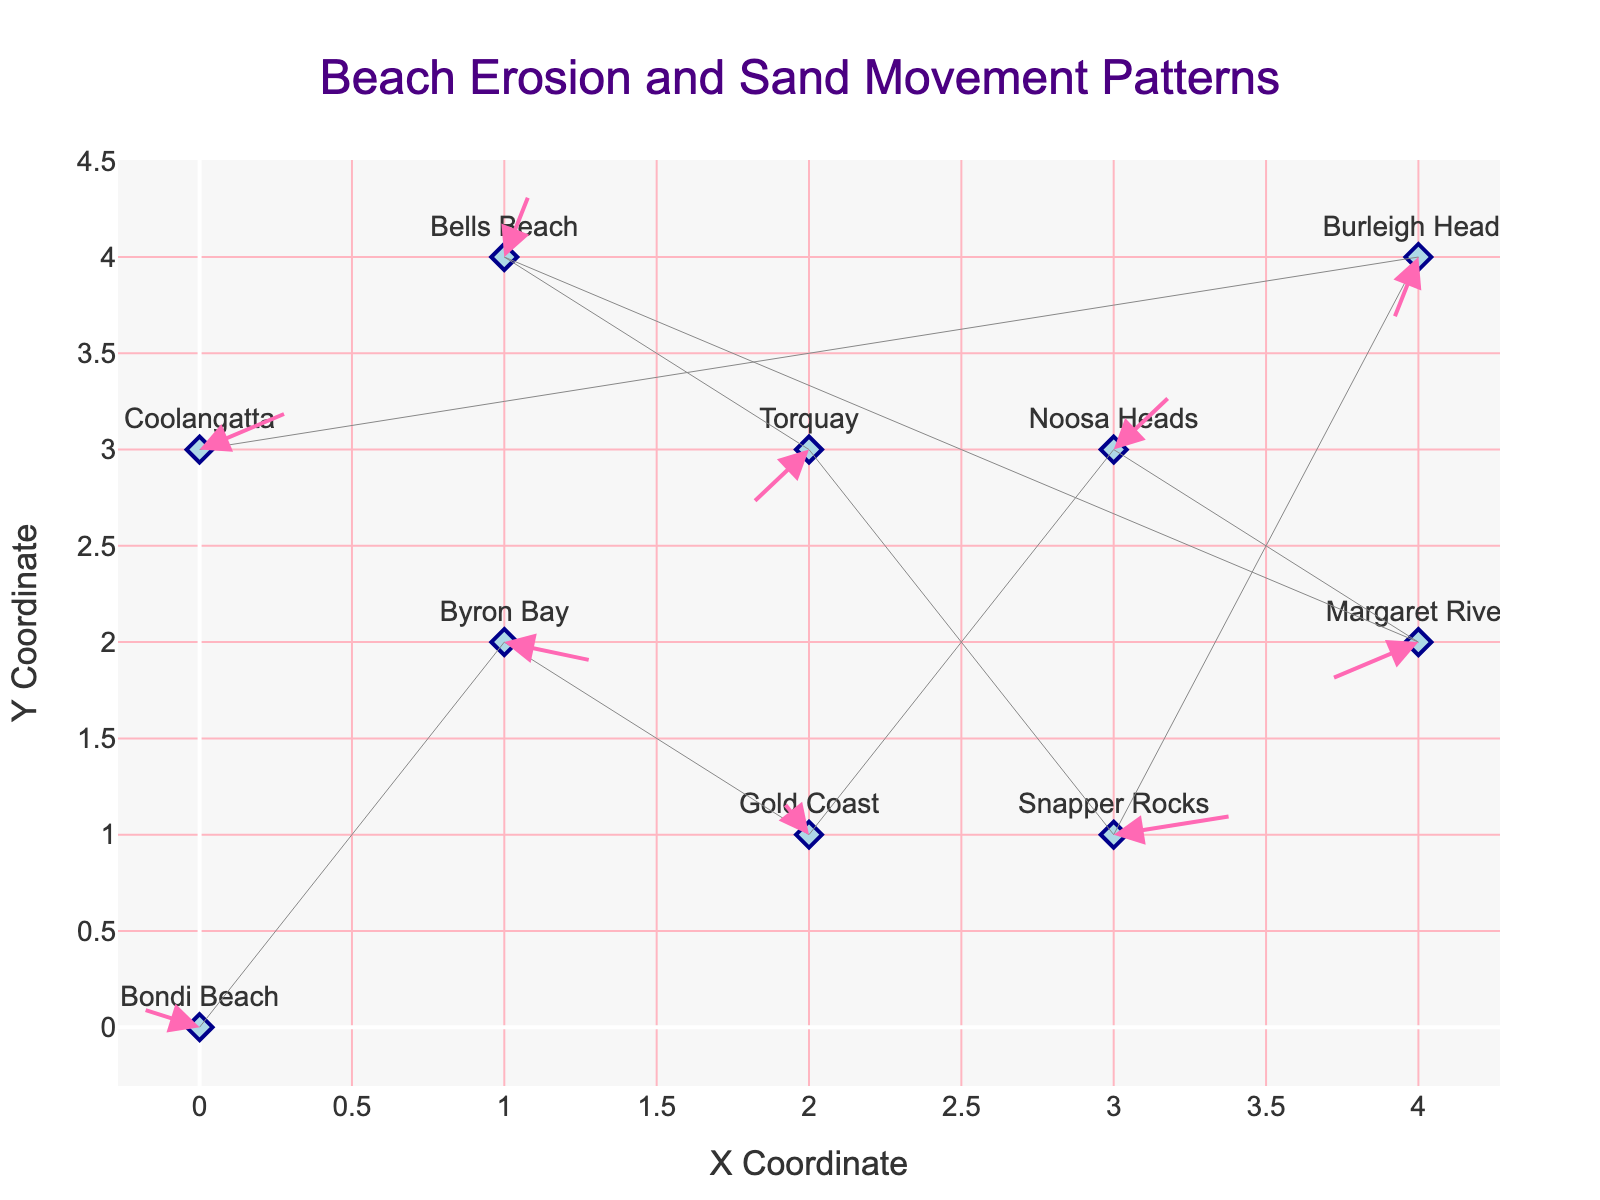How many locations are shown on the plot? Count the number of distinct markers on the plot; each represents a location. There are 10 markers, each corresponding to a different surfing beach.
Answer: 10 What is the title of the plot? Look at the title text at the top center of the plot. It reads "Beach Erosion and Sand Movement Patterns".
Answer: Beach Erosion and Sand Movement Patterns Which location has the largest horizontal sand movement? Examine the length of horizontal arrows in the plot. By comparing their lengths, you can see that Snapper Rocks has the largest horizontal movement (u=0.4).
Answer: Snapper Rocks What are the coordinates of Coolangatta, and in what direction is the sand moving there? Locate Coolangatta on the plot at the coordinates (0, 3). Notice the direction of the arrow originating from this point (u=0.3, v=0.2).
Answer: (0, 3), moving right and slightly up Which two locations have negative vertical sand movements, and which has the greatest downward movement? Look at the arrows' directions: downward implies negative vertical movement. Torquay (u=-0.2, v=-0.3) and Burleigh Heads (u=-0.1, v=-0.4) have arrows pointing downward, with Burleigh Heads showing the greatest downward movement.
Answer: Torquay and Burleigh Heads, greatest is Burleigh Heads What is the combined vector movement for Gold Coast? Both horizontal and vertical components can be combined using the Pythagorean theorem: sqrt((-0.1)^2 + 0.2^2) ≈ 0.22.
Answer: approximately 0.22 Which location on the plot has sand movement strictly to the left? Look for arrows pointing directly to the left; they have a negative horizontal component and zero vertical component. Margaret River (u=-0.3, v=-0.2) meets these criteria.
Answer: None Compare the sand movement at Byron Bay and Bells Beach, which one shows upward movement? Look at the direction of arrows at Byron Bay and Bells Beach. Byron Bay (u=0.3, v=-0.1) moves slightly downward, while Bells Beach (u=0.1, v=0.4) moves upward.
Answer: Bells Beach What is the average vertical movement across all locations? Sum the vertical components (0.1 + -0.1 + 0.2 + 0.3 + -0.2 + 0.4 + -0.3 + 0.1 + -0.4 + 0.2 = 0.3) and divide by the number of locations (10): 0.3/10 = 0.03.
Answer: 0.03 